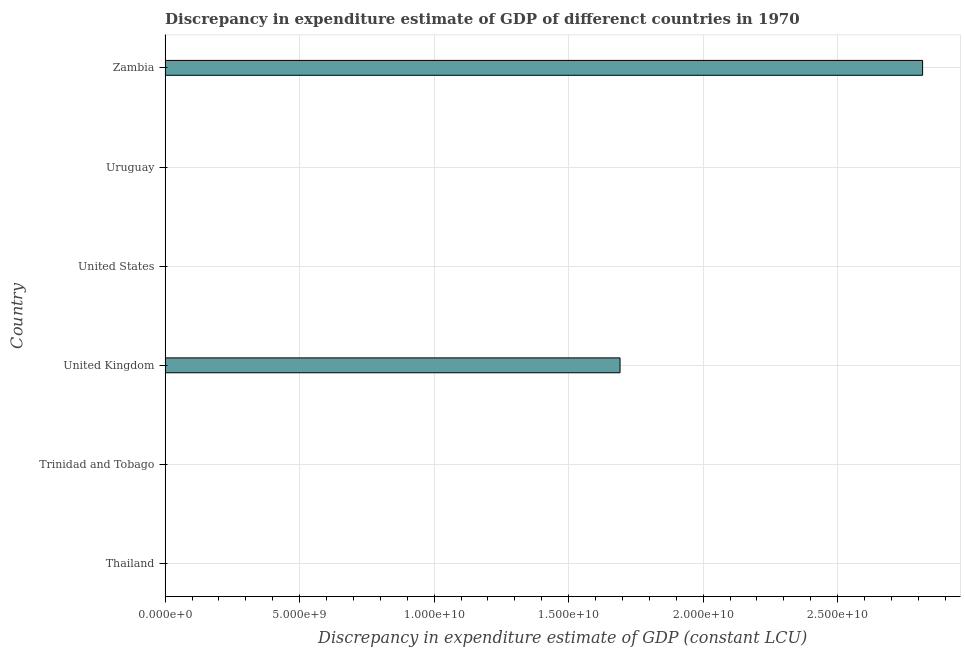What is the title of the graph?
Make the answer very short. Discrepancy in expenditure estimate of GDP of differenct countries in 1970. What is the label or title of the X-axis?
Your response must be concise. Discrepancy in expenditure estimate of GDP (constant LCU). What is the label or title of the Y-axis?
Make the answer very short. Country. Across all countries, what is the maximum discrepancy in expenditure estimate of gdp?
Offer a very short reply. 2.82e+1. Across all countries, what is the minimum discrepancy in expenditure estimate of gdp?
Your answer should be very brief. 0. In which country was the discrepancy in expenditure estimate of gdp maximum?
Offer a terse response. Zambia. What is the sum of the discrepancy in expenditure estimate of gdp?
Offer a very short reply. 4.51e+1. What is the average discrepancy in expenditure estimate of gdp per country?
Give a very brief answer. 7.51e+09. What is the ratio of the discrepancy in expenditure estimate of gdp in United Kingdom to that in Zambia?
Provide a short and direct response. 0.6. What is the difference between the highest and the lowest discrepancy in expenditure estimate of gdp?
Your answer should be compact. 2.82e+1. In how many countries, is the discrepancy in expenditure estimate of gdp greater than the average discrepancy in expenditure estimate of gdp taken over all countries?
Your response must be concise. 2. What is the Discrepancy in expenditure estimate of GDP (constant LCU) of Trinidad and Tobago?
Ensure brevity in your answer.  0. What is the Discrepancy in expenditure estimate of GDP (constant LCU) of United Kingdom?
Keep it short and to the point. 1.69e+1. What is the Discrepancy in expenditure estimate of GDP (constant LCU) in Zambia?
Ensure brevity in your answer.  2.82e+1. What is the difference between the Discrepancy in expenditure estimate of GDP (constant LCU) in United Kingdom and Zambia?
Ensure brevity in your answer.  -1.12e+1. What is the ratio of the Discrepancy in expenditure estimate of GDP (constant LCU) in United Kingdom to that in Zambia?
Offer a very short reply. 0.6. 